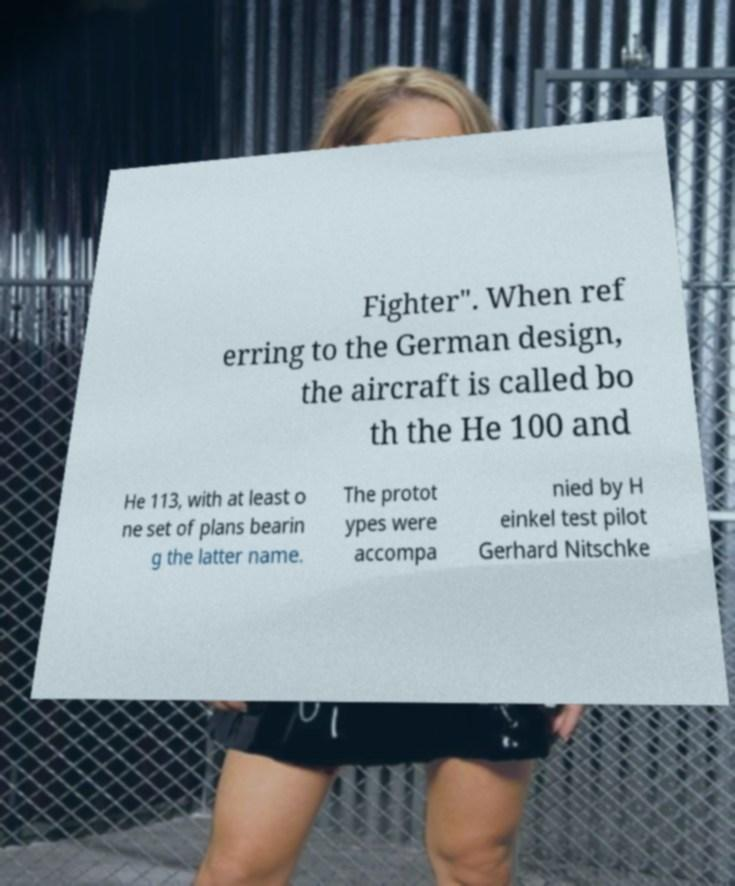Can you accurately transcribe the text from the provided image for me? Fighter". When ref erring to the German design, the aircraft is called bo th the He 100 and He 113, with at least o ne set of plans bearin g the latter name. The protot ypes were accompa nied by H einkel test pilot Gerhard Nitschke 